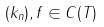Convert formula to latex. <formula><loc_0><loc_0><loc_500><loc_500>( k _ { n } ) , f \in C ( T )</formula> 